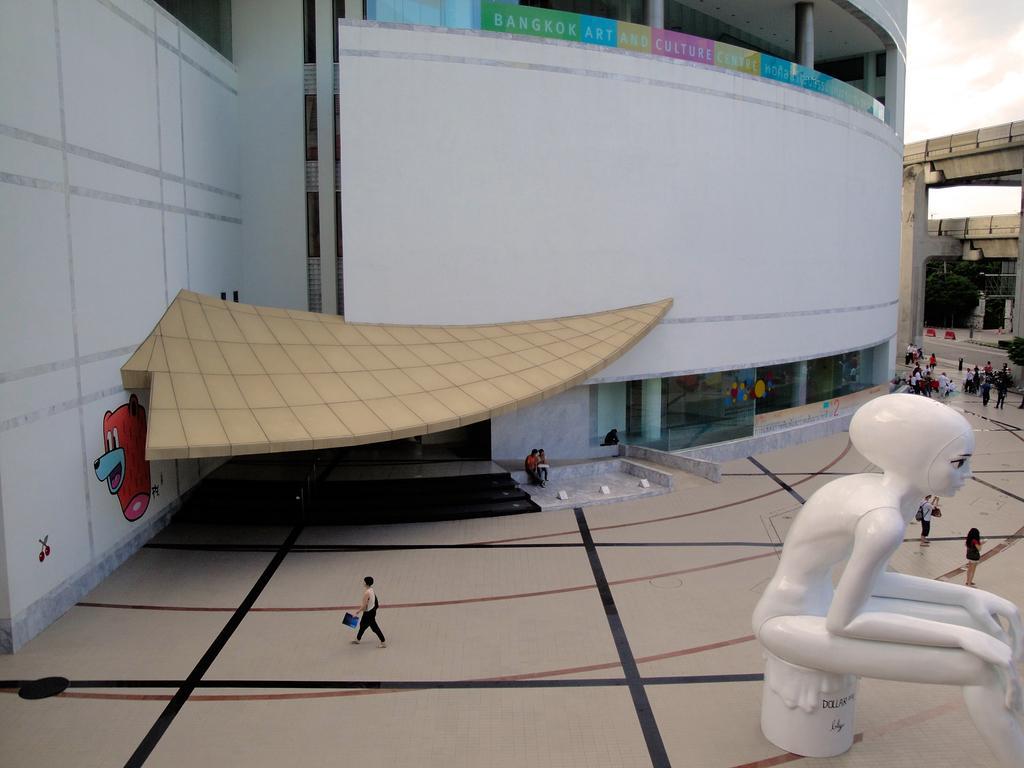Can you describe this image briefly? At the bottom of the image on the floor there are many people standing. On the right side of the image there is a statue. And in the image there is a building with walls, pillars, glass walls and also there are steps. On the left side of the image there is a wall with few images on it. And on the right side of the image there are pillars and also there are trees. 